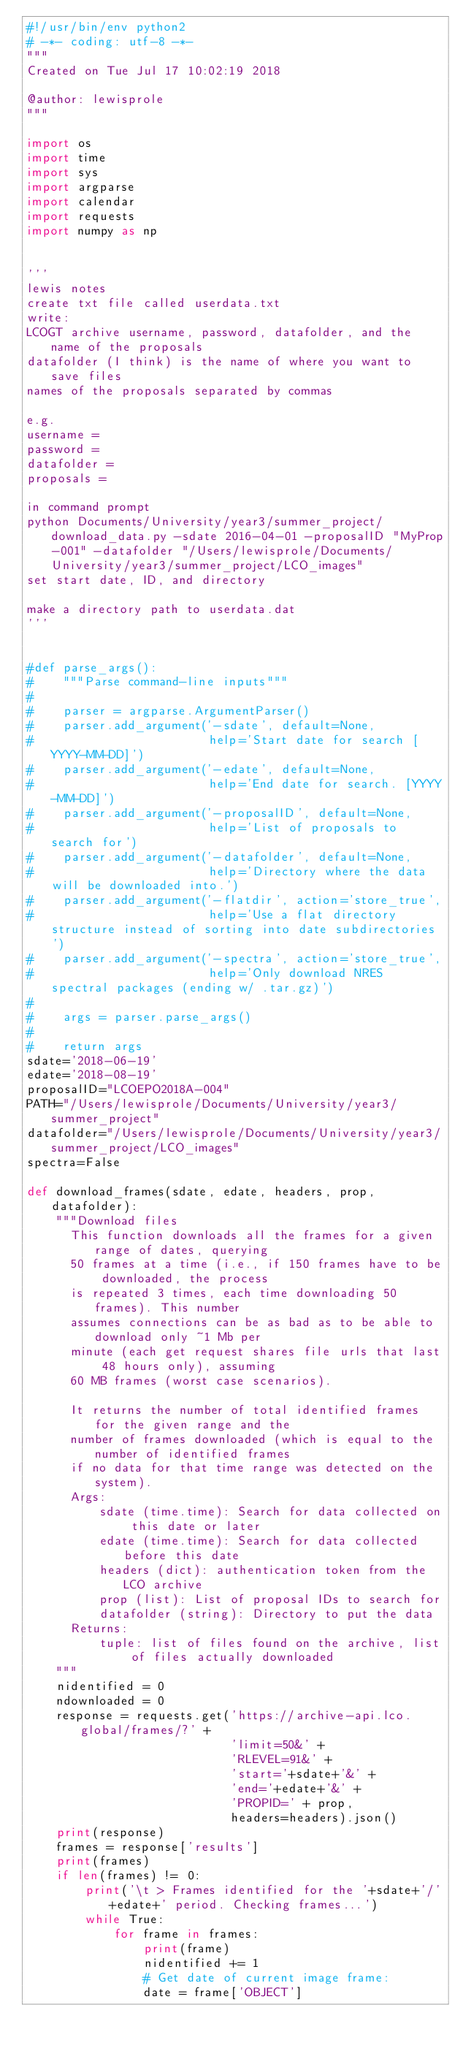Convert code to text. <code><loc_0><loc_0><loc_500><loc_500><_Python_>#!/usr/bin/env python2
# -*- coding: utf-8 -*-
"""
Created on Tue Jul 17 10:02:19 2018

@author: lewisprole
"""

import os
import time
import sys
import argparse
import calendar
import requests
import numpy as np


'''
lewis notes
create txt file called userdata.txt
write:
LCOGT archive username, password, datafolder, and the name of the proposals
datafolder (I think) is the name of where you want to save files 
names of the proposals separated by commas 

e.g.
username = 
password = 
datafolder = 
proposals = 

in command prompt 
python Documents/University/year3/summer_project/download_data.py -sdate 2016-04-01 -proposalID "MyProp-001" -datafolder "/Users/lewisprole/Documents/University/year3/summer_project/LCO_images"
set start date, ID, and directory

make a directory path to userdata.dat
'''


#def parse_args():
#    """Parse command-line inputs"""
#
#    parser = argparse.ArgumentParser()
#    parser.add_argument('-sdate', default=None,
#                        help='Start date for search [YYYY-MM-DD]')
#    parser.add_argument('-edate', default=None,
#                        help='End date for search. [YYYY-MM-DD]')
#    parser.add_argument('-proposalID', default=None,
#                        help='List of proposals to search for')
#    parser.add_argument('-datafolder', default=None,
#                        help='Directory where the data will be downloaded into.')
#    parser.add_argument('-flatdir', action='store_true',
#                        help='Use a flat directory structure instead of sorting into date subdirectories')
#    parser.add_argument('-spectra', action='store_true',
#                        help='Only download NRES spectral packages (ending w/ .tar.gz)')
#
#    args = parser.parse_args()
#
#    return args
sdate='2018-06-19'
edate='2018-08-19'
proposalID="LCOEPO2018A-004"
PATH="/Users/lewisprole/Documents/University/year3/summer_project"
datafolder="/Users/lewisprole/Documents/University/year3/summer_project/LCO_images"
spectra=False

def download_frames(sdate, edate, headers, prop, datafolder):
    """Download files
      This function downloads all the frames for a given range of dates, querying
      50 frames at a time (i.e., if 150 frames have to be downloaded, the process 
      is repeated 3 times, each time downloading 50 frames). This number 
      assumes connections can be as bad as to be able to download only ~1 Mb per 
      minute (each get request shares file urls that last 48 hours only), assuming 
      60 MB frames (worst case scenarios).
 
      It returns the number of total identified frames for the given range and the 
      number of frames downloaded (which is equal to the number of identified frames 
      if no data for that time range was detected on the system).
      Args:
          sdate (time.time): Search for data collected on this date or later
          edate (time.time): Search for data collected before this date
          headers (dict): authentication token from the LCO archive
          prop (list): List of proposal IDs to search for
          datafolder (string): Directory to put the data
      Returns:
          tuple: list of files found on the archive, list of files actually downloaded
    """
    nidentified = 0
    ndownloaded = 0
    response = requests.get('https://archive-api.lco.global/frames/?' +
                            'limit=50&' +
                            'RLEVEL=91&' +
                            'start='+sdate+'&' +
                            'end='+edate+'&' +
                            'PROPID=' + prop,
                            headers=headers).json()
    print(response)
    frames = response['results']
    print(frames)
    if len(frames) != 0:
        print('\t > Frames identified for the '+sdate+'/'+edate+' period. Checking frames...')
        while True:
            for frame in frames:
                print(frame)
                nidentified += 1
                # Get date of current image frame:
                date = frame['OBJECT']
</code> 